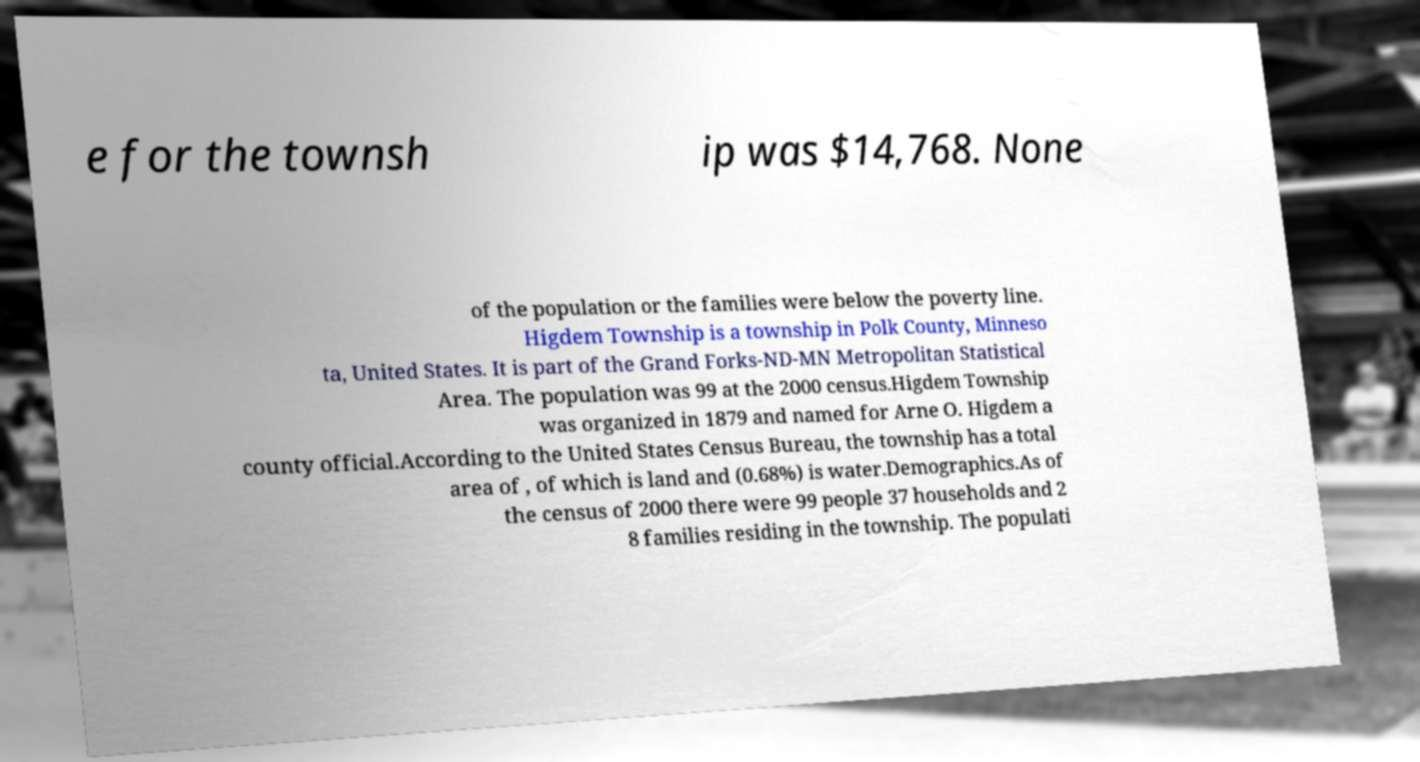Can you accurately transcribe the text from the provided image for me? e for the townsh ip was $14,768. None of the population or the families were below the poverty line. Higdem Township is a township in Polk County, Minneso ta, United States. It is part of the Grand Forks-ND-MN Metropolitan Statistical Area. The population was 99 at the 2000 census.Higdem Township was organized in 1879 and named for Arne O. Higdem a county official.According to the United States Census Bureau, the township has a total area of , of which is land and (0.68%) is water.Demographics.As of the census of 2000 there were 99 people 37 households and 2 8 families residing in the township. The populati 